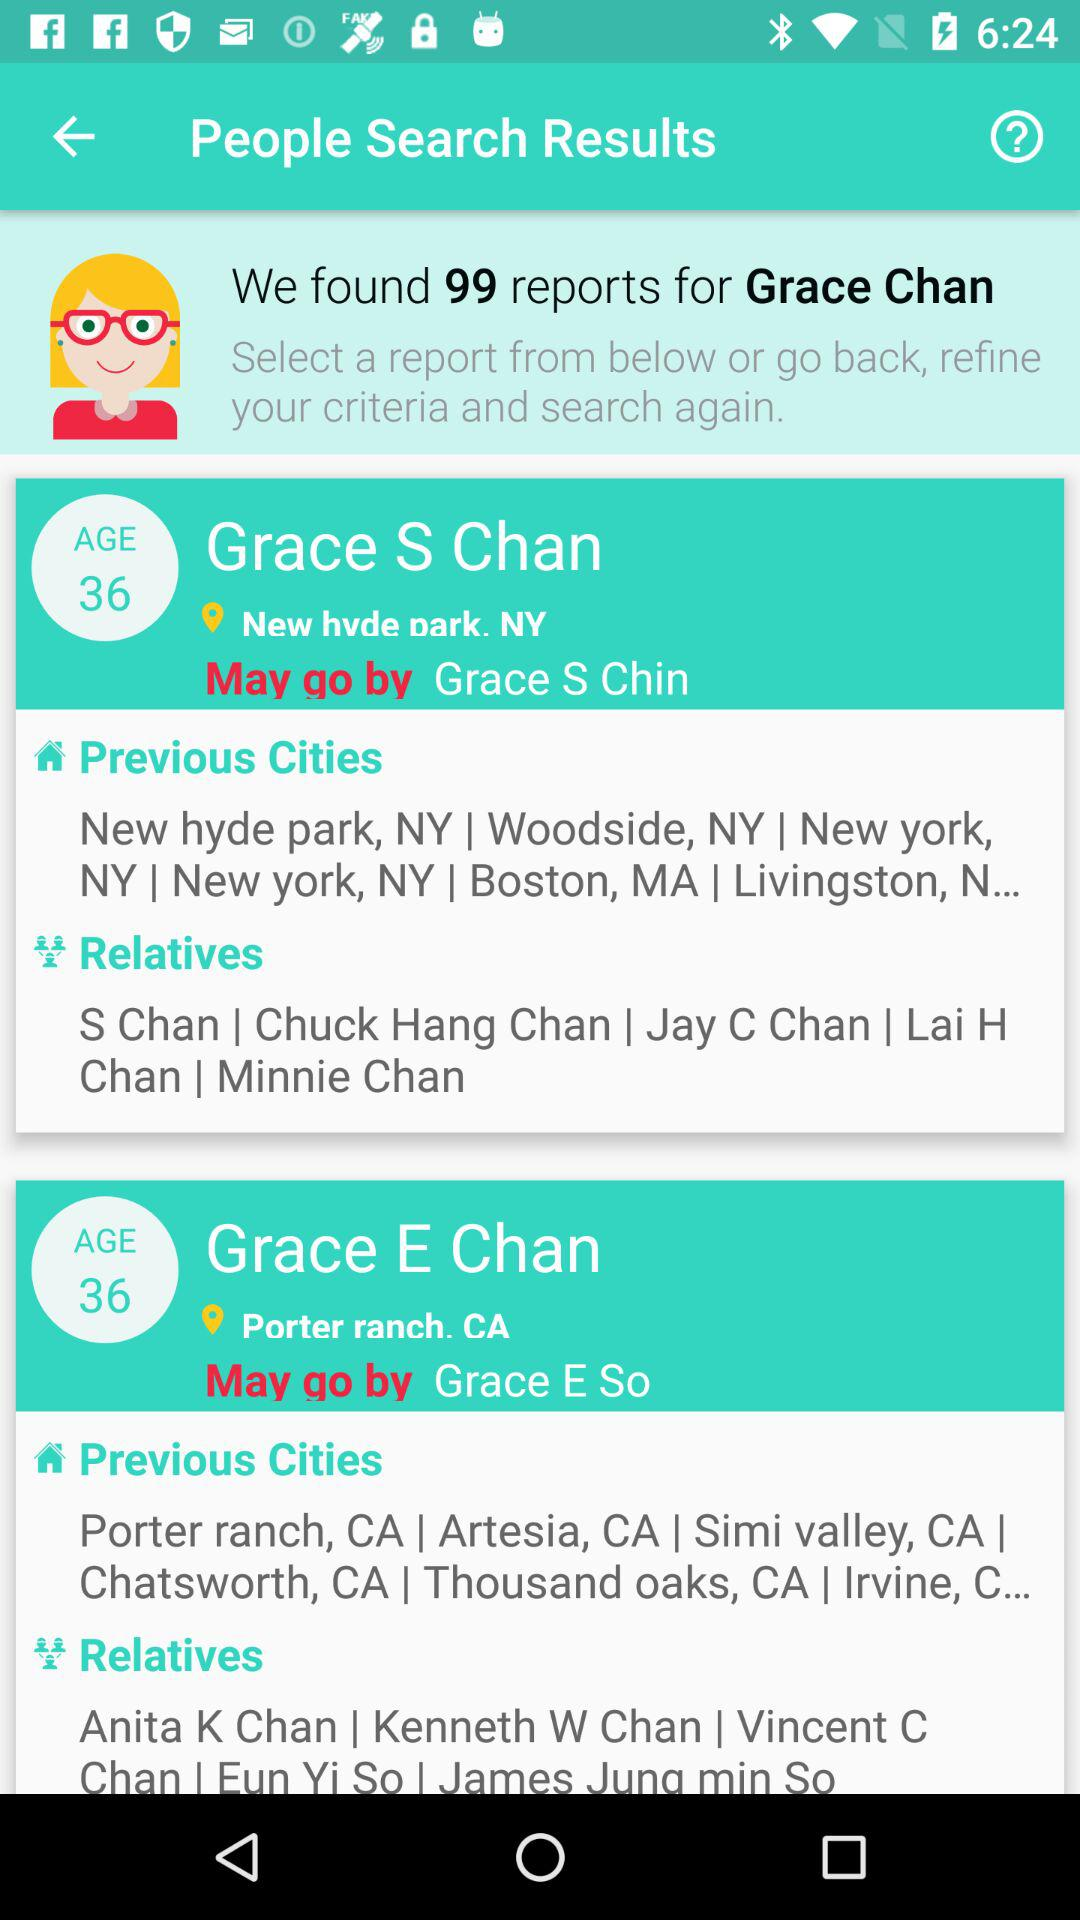How many reports were found for Grace Chan? For Grace Chan, 99 reports were found. 